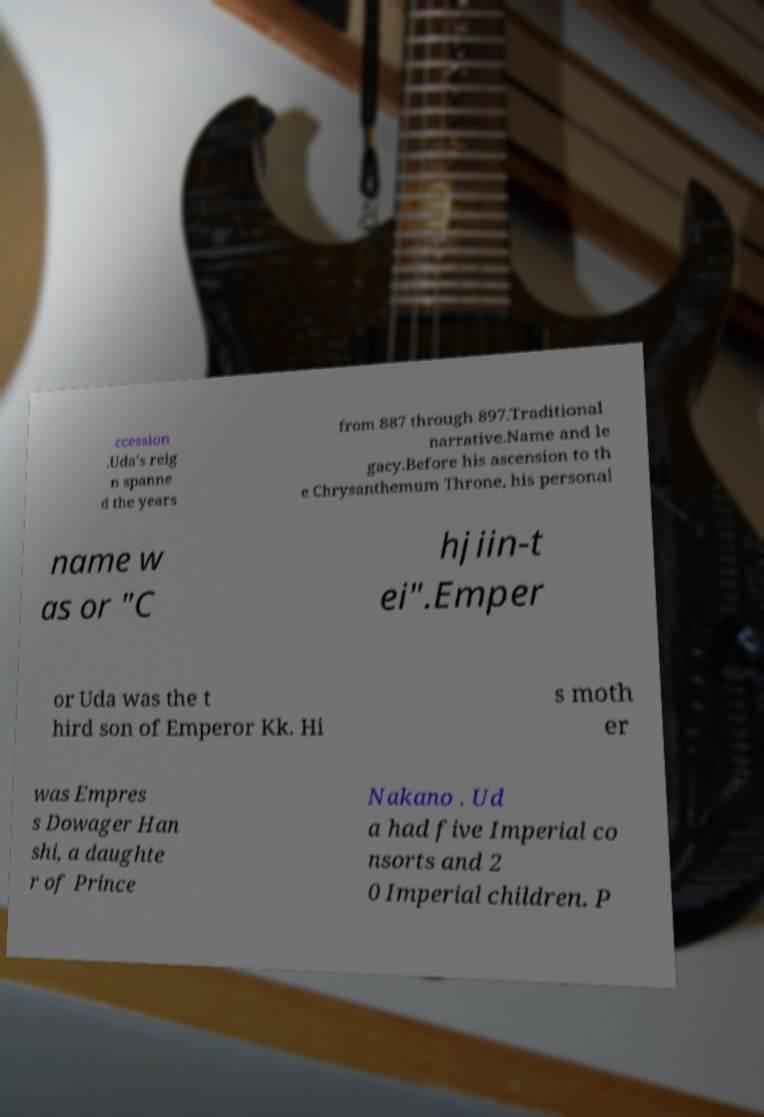There's text embedded in this image that I need extracted. Can you transcribe it verbatim? ccession .Uda's reig n spanne d the years from 887 through 897.Traditional narrative.Name and le gacy.Before his ascension to th e Chrysanthemum Throne, his personal name w as or "C hjiin-t ei".Emper or Uda was the t hird son of Emperor Kk. Hi s moth er was Empres s Dowager Han shi, a daughte r of Prince Nakano . Ud a had five Imperial co nsorts and 2 0 Imperial children. P 